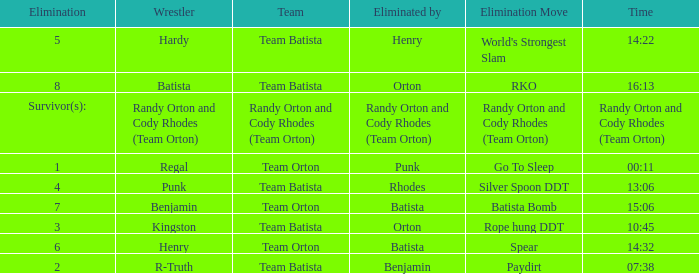What is the Elimination move listed against Regal? Go To Sleep. 